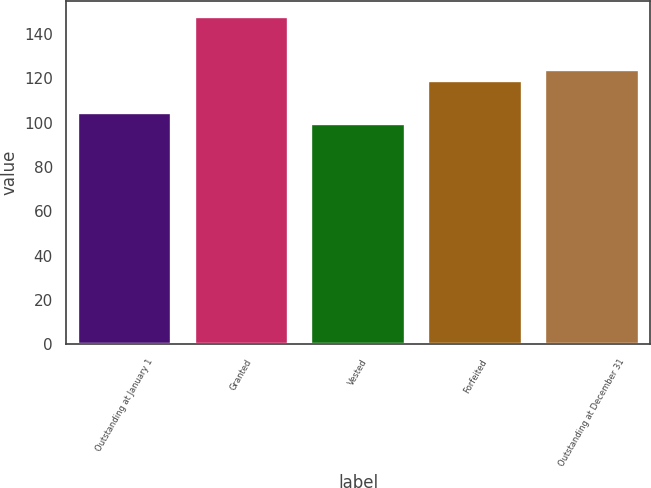Convert chart. <chart><loc_0><loc_0><loc_500><loc_500><bar_chart><fcel>Outstanding at January 1<fcel>Granted<fcel>Vested<fcel>Forfeited<fcel>Outstanding at December 31<nl><fcel>104.34<fcel>147.44<fcel>99.55<fcel>118.82<fcel>123.61<nl></chart> 